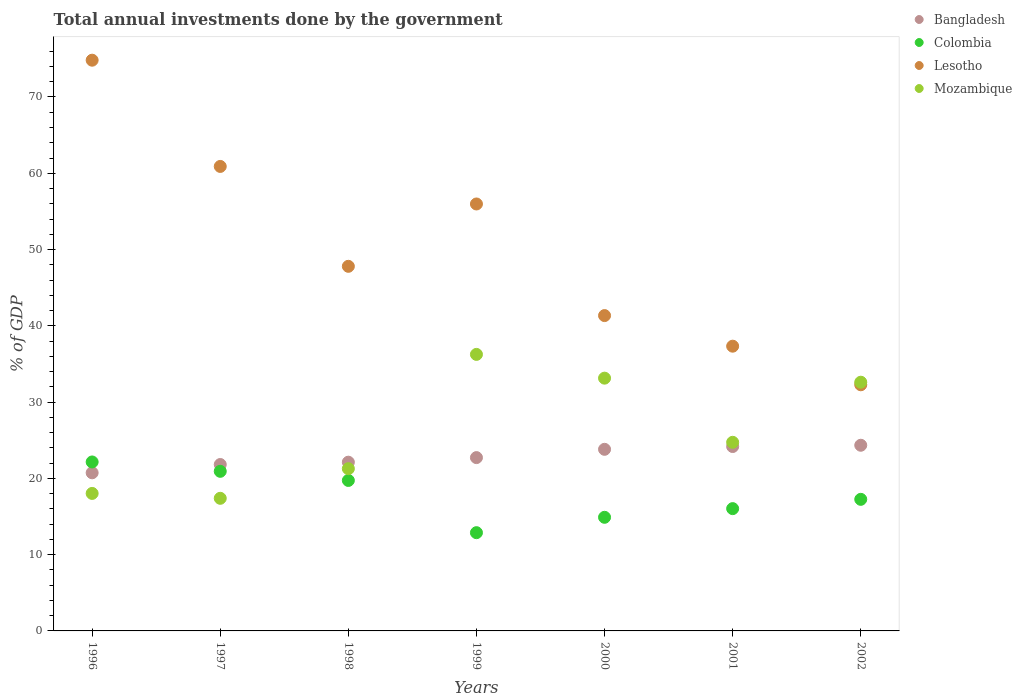How many different coloured dotlines are there?
Offer a very short reply. 4. What is the total annual investments done by the government in Bangladesh in 1997?
Offer a very short reply. 21.82. Across all years, what is the maximum total annual investments done by the government in Lesotho?
Make the answer very short. 74.82. Across all years, what is the minimum total annual investments done by the government in Lesotho?
Your answer should be compact. 32.27. In which year was the total annual investments done by the government in Bangladesh minimum?
Make the answer very short. 1996. What is the total total annual investments done by the government in Lesotho in the graph?
Offer a very short reply. 350.43. What is the difference between the total annual investments done by the government in Lesotho in 1996 and that in 1997?
Provide a short and direct response. 13.93. What is the difference between the total annual investments done by the government in Bangladesh in 1999 and the total annual investments done by the government in Colombia in 1996?
Make the answer very short. 0.57. What is the average total annual investments done by the government in Lesotho per year?
Offer a terse response. 50.06. In the year 1998, what is the difference between the total annual investments done by the government in Colombia and total annual investments done by the government in Bangladesh?
Provide a succinct answer. -2.39. What is the ratio of the total annual investments done by the government in Mozambique in 1997 to that in 1998?
Keep it short and to the point. 0.82. Is the total annual investments done by the government in Bangladesh in 1996 less than that in 2001?
Offer a terse response. Yes. What is the difference between the highest and the second highest total annual investments done by the government in Mozambique?
Give a very brief answer. 3.12. What is the difference between the highest and the lowest total annual investments done by the government in Colombia?
Your response must be concise. 9.27. Is it the case that in every year, the sum of the total annual investments done by the government in Lesotho and total annual investments done by the government in Mozambique  is greater than the sum of total annual investments done by the government in Colombia and total annual investments done by the government in Bangladesh?
Provide a short and direct response. Yes. Is it the case that in every year, the sum of the total annual investments done by the government in Colombia and total annual investments done by the government in Lesotho  is greater than the total annual investments done by the government in Bangladesh?
Provide a short and direct response. Yes. Is the total annual investments done by the government in Colombia strictly greater than the total annual investments done by the government in Bangladesh over the years?
Offer a terse response. No. How many dotlines are there?
Give a very brief answer. 4. How many years are there in the graph?
Give a very brief answer. 7. What is the difference between two consecutive major ticks on the Y-axis?
Offer a very short reply. 10. Are the values on the major ticks of Y-axis written in scientific E-notation?
Your answer should be compact. No. How many legend labels are there?
Provide a short and direct response. 4. How are the legend labels stacked?
Your answer should be compact. Vertical. What is the title of the graph?
Keep it short and to the point. Total annual investments done by the government. What is the label or title of the Y-axis?
Make the answer very short. % of GDP. What is the % of GDP in Bangladesh in 1996?
Your answer should be compact. 20.73. What is the % of GDP of Colombia in 1996?
Your answer should be very brief. 22.15. What is the % of GDP of Lesotho in 1996?
Make the answer very short. 74.82. What is the % of GDP of Mozambique in 1996?
Keep it short and to the point. 18.03. What is the % of GDP of Bangladesh in 1997?
Ensure brevity in your answer.  21.82. What is the % of GDP in Colombia in 1997?
Offer a terse response. 20.92. What is the % of GDP in Lesotho in 1997?
Keep it short and to the point. 60.89. What is the % of GDP of Mozambique in 1997?
Offer a terse response. 17.39. What is the % of GDP in Bangladesh in 1998?
Provide a short and direct response. 22.12. What is the % of GDP in Colombia in 1998?
Make the answer very short. 19.73. What is the % of GDP in Lesotho in 1998?
Give a very brief answer. 47.8. What is the % of GDP in Mozambique in 1998?
Your answer should be compact. 21.27. What is the % of GDP of Bangladesh in 1999?
Make the answer very short. 22.72. What is the % of GDP in Colombia in 1999?
Provide a succinct answer. 12.88. What is the % of GDP of Lesotho in 1999?
Make the answer very short. 55.97. What is the % of GDP in Mozambique in 1999?
Make the answer very short. 36.25. What is the % of GDP of Bangladesh in 2000?
Give a very brief answer. 23.81. What is the % of GDP of Colombia in 2000?
Provide a short and direct response. 14.9. What is the % of GDP of Lesotho in 2000?
Your answer should be very brief. 41.34. What is the % of GDP of Mozambique in 2000?
Give a very brief answer. 33.14. What is the % of GDP of Bangladesh in 2001?
Offer a very short reply. 24.17. What is the % of GDP in Colombia in 2001?
Your response must be concise. 16.03. What is the % of GDP in Lesotho in 2001?
Give a very brief answer. 37.33. What is the % of GDP in Mozambique in 2001?
Make the answer very short. 24.73. What is the % of GDP in Bangladesh in 2002?
Give a very brief answer. 24.34. What is the % of GDP of Colombia in 2002?
Offer a very short reply. 17.25. What is the % of GDP of Lesotho in 2002?
Your answer should be very brief. 32.27. What is the % of GDP in Mozambique in 2002?
Provide a succinct answer. 32.61. Across all years, what is the maximum % of GDP in Bangladesh?
Your answer should be very brief. 24.34. Across all years, what is the maximum % of GDP in Colombia?
Your answer should be compact. 22.15. Across all years, what is the maximum % of GDP of Lesotho?
Make the answer very short. 74.82. Across all years, what is the maximum % of GDP of Mozambique?
Make the answer very short. 36.25. Across all years, what is the minimum % of GDP in Bangladesh?
Your response must be concise. 20.73. Across all years, what is the minimum % of GDP in Colombia?
Give a very brief answer. 12.88. Across all years, what is the minimum % of GDP of Lesotho?
Offer a terse response. 32.27. Across all years, what is the minimum % of GDP in Mozambique?
Your answer should be very brief. 17.39. What is the total % of GDP in Bangladesh in the graph?
Offer a terse response. 159.71. What is the total % of GDP of Colombia in the graph?
Offer a very short reply. 123.86. What is the total % of GDP in Lesotho in the graph?
Ensure brevity in your answer.  350.43. What is the total % of GDP in Mozambique in the graph?
Provide a short and direct response. 183.41. What is the difference between the % of GDP of Bangladesh in 1996 and that in 1997?
Offer a very short reply. -1.09. What is the difference between the % of GDP of Colombia in 1996 and that in 1997?
Your response must be concise. 1.23. What is the difference between the % of GDP in Lesotho in 1996 and that in 1997?
Make the answer very short. 13.93. What is the difference between the % of GDP in Mozambique in 1996 and that in 1997?
Your answer should be very brief. 0.64. What is the difference between the % of GDP of Bangladesh in 1996 and that in 1998?
Keep it short and to the point. -1.39. What is the difference between the % of GDP of Colombia in 1996 and that in 1998?
Offer a terse response. 2.42. What is the difference between the % of GDP in Lesotho in 1996 and that in 1998?
Provide a short and direct response. 27.02. What is the difference between the % of GDP of Mozambique in 1996 and that in 1998?
Offer a very short reply. -3.24. What is the difference between the % of GDP of Bangladesh in 1996 and that in 1999?
Offer a very short reply. -1.99. What is the difference between the % of GDP of Colombia in 1996 and that in 1999?
Provide a succinct answer. 9.27. What is the difference between the % of GDP of Lesotho in 1996 and that in 1999?
Offer a terse response. 18.85. What is the difference between the % of GDP in Mozambique in 1996 and that in 1999?
Your answer should be compact. -18.23. What is the difference between the % of GDP in Bangladesh in 1996 and that in 2000?
Offer a very short reply. -3.08. What is the difference between the % of GDP of Colombia in 1996 and that in 2000?
Your answer should be compact. 7.26. What is the difference between the % of GDP in Lesotho in 1996 and that in 2000?
Your response must be concise. 33.48. What is the difference between the % of GDP in Mozambique in 1996 and that in 2000?
Give a very brief answer. -15.11. What is the difference between the % of GDP of Bangladesh in 1996 and that in 2001?
Offer a very short reply. -3.44. What is the difference between the % of GDP of Colombia in 1996 and that in 2001?
Offer a terse response. 6.12. What is the difference between the % of GDP in Lesotho in 1996 and that in 2001?
Provide a short and direct response. 37.49. What is the difference between the % of GDP of Mozambique in 1996 and that in 2001?
Ensure brevity in your answer.  -6.7. What is the difference between the % of GDP in Bangladesh in 1996 and that in 2002?
Your answer should be very brief. -3.61. What is the difference between the % of GDP of Colombia in 1996 and that in 2002?
Offer a terse response. 4.9. What is the difference between the % of GDP in Lesotho in 1996 and that in 2002?
Provide a succinct answer. 42.55. What is the difference between the % of GDP in Mozambique in 1996 and that in 2002?
Keep it short and to the point. -14.58. What is the difference between the % of GDP of Bangladesh in 1997 and that in 1998?
Keep it short and to the point. -0.31. What is the difference between the % of GDP of Colombia in 1997 and that in 1998?
Your answer should be very brief. 1.2. What is the difference between the % of GDP of Lesotho in 1997 and that in 1998?
Your answer should be very brief. 13.1. What is the difference between the % of GDP in Mozambique in 1997 and that in 1998?
Provide a short and direct response. -3.88. What is the difference between the % of GDP in Bangladesh in 1997 and that in 1999?
Offer a terse response. -0.91. What is the difference between the % of GDP of Colombia in 1997 and that in 1999?
Provide a short and direct response. 8.04. What is the difference between the % of GDP in Lesotho in 1997 and that in 1999?
Provide a succinct answer. 4.92. What is the difference between the % of GDP of Mozambique in 1997 and that in 1999?
Your answer should be compact. -18.87. What is the difference between the % of GDP of Bangladesh in 1997 and that in 2000?
Offer a very short reply. -1.99. What is the difference between the % of GDP in Colombia in 1997 and that in 2000?
Your answer should be compact. 6.03. What is the difference between the % of GDP of Lesotho in 1997 and that in 2000?
Keep it short and to the point. 19.55. What is the difference between the % of GDP in Mozambique in 1997 and that in 2000?
Give a very brief answer. -15.75. What is the difference between the % of GDP in Bangladesh in 1997 and that in 2001?
Offer a terse response. -2.36. What is the difference between the % of GDP in Colombia in 1997 and that in 2001?
Your response must be concise. 4.89. What is the difference between the % of GDP in Lesotho in 1997 and that in 2001?
Provide a short and direct response. 23.57. What is the difference between the % of GDP of Mozambique in 1997 and that in 2001?
Your answer should be compact. -7.34. What is the difference between the % of GDP in Bangladesh in 1997 and that in 2002?
Your response must be concise. -2.53. What is the difference between the % of GDP in Colombia in 1997 and that in 2002?
Provide a succinct answer. 3.67. What is the difference between the % of GDP of Lesotho in 1997 and that in 2002?
Provide a short and direct response. 28.62. What is the difference between the % of GDP in Mozambique in 1997 and that in 2002?
Give a very brief answer. -15.22. What is the difference between the % of GDP of Colombia in 1998 and that in 1999?
Your response must be concise. 6.85. What is the difference between the % of GDP of Lesotho in 1998 and that in 1999?
Give a very brief answer. -8.17. What is the difference between the % of GDP in Mozambique in 1998 and that in 1999?
Your answer should be compact. -14.98. What is the difference between the % of GDP of Bangladesh in 1998 and that in 2000?
Your answer should be very brief. -1.69. What is the difference between the % of GDP in Colombia in 1998 and that in 2000?
Keep it short and to the point. 4.83. What is the difference between the % of GDP in Lesotho in 1998 and that in 2000?
Your response must be concise. 6.46. What is the difference between the % of GDP of Mozambique in 1998 and that in 2000?
Keep it short and to the point. -11.87. What is the difference between the % of GDP in Bangladesh in 1998 and that in 2001?
Make the answer very short. -2.05. What is the difference between the % of GDP of Colombia in 1998 and that in 2001?
Your answer should be compact. 3.7. What is the difference between the % of GDP of Lesotho in 1998 and that in 2001?
Make the answer very short. 10.47. What is the difference between the % of GDP in Mozambique in 1998 and that in 2001?
Provide a short and direct response. -3.46. What is the difference between the % of GDP in Bangladesh in 1998 and that in 2002?
Ensure brevity in your answer.  -2.22. What is the difference between the % of GDP in Colombia in 1998 and that in 2002?
Your response must be concise. 2.48. What is the difference between the % of GDP in Lesotho in 1998 and that in 2002?
Make the answer very short. 15.53. What is the difference between the % of GDP in Mozambique in 1998 and that in 2002?
Offer a very short reply. -11.34. What is the difference between the % of GDP of Bangladesh in 1999 and that in 2000?
Ensure brevity in your answer.  -1.09. What is the difference between the % of GDP of Colombia in 1999 and that in 2000?
Keep it short and to the point. -2.02. What is the difference between the % of GDP in Lesotho in 1999 and that in 2000?
Offer a terse response. 14.63. What is the difference between the % of GDP of Mozambique in 1999 and that in 2000?
Provide a succinct answer. 3.12. What is the difference between the % of GDP of Bangladesh in 1999 and that in 2001?
Provide a short and direct response. -1.45. What is the difference between the % of GDP in Colombia in 1999 and that in 2001?
Provide a succinct answer. -3.15. What is the difference between the % of GDP in Lesotho in 1999 and that in 2001?
Keep it short and to the point. 18.64. What is the difference between the % of GDP of Mozambique in 1999 and that in 2001?
Your answer should be compact. 11.53. What is the difference between the % of GDP of Bangladesh in 1999 and that in 2002?
Give a very brief answer. -1.62. What is the difference between the % of GDP in Colombia in 1999 and that in 2002?
Your response must be concise. -4.37. What is the difference between the % of GDP of Lesotho in 1999 and that in 2002?
Provide a succinct answer. 23.7. What is the difference between the % of GDP of Mozambique in 1999 and that in 2002?
Provide a short and direct response. 3.65. What is the difference between the % of GDP in Bangladesh in 2000 and that in 2001?
Offer a very short reply. -0.37. What is the difference between the % of GDP of Colombia in 2000 and that in 2001?
Offer a very short reply. -1.14. What is the difference between the % of GDP in Lesotho in 2000 and that in 2001?
Ensure brevity in your answer.  4.01. What is the difference between the % of GDP of Mozambique in 2000 and that in 2001?
Offer a terse response. 8.41. What is the difference between the % of GDP in Bangladesh in 2000 and that in 2002?
Offer a terse response. -0.53. What is the difference between the % of GDP in Colombia in 2000 and that in 2002?
Give a very brief answer. -2.36. What is the difference between the % of GDP in Lesotho in 2000 and that in 2002?
Provide a short and direct response. 9.07. What is the difference between the % of GDP of Mozambique in 2000 and that in 2002?
Offer a terse response. 0.53. What is the difference between the % of GDP of Bangladesh in 2001 and that in 2002?
Make the answer very short. -0.17. What is the difference between the % of GDP in Colombia in 2001 and that in 2002?
Give a very brief answer. -1.22. What is the difference between the % of GDP in Lesotho in 2001 and that in 2002?
Ensure brevity in your answer.  5.06. What is the difference between the % of GDP in Mozambique in 2001 and that in 2002?
Your answer should be very brief. -7.88. What is the difference between the % of GDP in Bangladesh in 1996 and the % of GDP in Colombia in 1997?
Provide a succinct answer. -0.19. What is the difference between the % of GDP of Bangladesh in 1996 and the % of GDP of Lesotho in 1997?
Offer a very short reply. -40.16. What is the difference between the % of GDP in Bangladesh in 1996 and the % of GDP in Mozambique in 1997?
Ensure brevity in your answer.  3.34. What is the difference between the % of GDP of Colombia in 1996 and the % of GDP of Lesotho in 1997?
Your answer should be compact. -38.74. What is the difference between the % of GDP in Colombia in 1996 and the % of GDP in Mozambique in 1997?
Keep it short and to the point. 4.77. What is the difference between the % of GDP of Lesotho in 1996 and the % of GDP of Mozambique in 1997?
Give a very brief answer. 57.44. What is the difference between the % of GDP in Bangladesh in 1996 and the % of GDP in Colombia in 1998?
Keep it short and to the point. 1. What is the difference between the % of GDP of Bangladesh in 1996 and the % of GDP of Lesotho in 1998?
Your answer should be very brief. -27.07. What is the difference between the % of GDP in Bangladesh in 1996 and the % of GDP in Mozambique in 1998?
Make the answer very short. -0.54. What is the difference between the % of GDP of Colombia in 1996 and the % of GDP of Lesotho in 1998?
Ensure brevity in your answer.  -25.65. What is the difference between the % of GDP of Colombia in 1996 and the % of GDP of Mozambique in 1998?
Offer a terse response. 0.88. What is the difference between the % of GDP in Lesotho in 1996 and the % of GDP in Mozambique in 1998?
Your answer should be compact. 53.55. What is the difference between the % of GDP in Bangladesh in 1996 and the % of GDP in Colombia in 1999?
Your answer should be compact. 7.85. What is the difference between the % of GDP of Bangladesh in 1996 and the % of GDP of Lesotho in 1999?
Offer a very short reply. -35.24. What is the difference between the % of GDP of Bangladesh in 1996 and the % of GDP of Mozambique in 1999?
Your response must be concise. -15.52. What is the difference between the % of GDP in Colombia in 1996 and the % of GDP in Lesotho in 1999?
Your answer should be compact. -33.82. What is the difference between the % of GDP in Colombia in 1996 and the % of GDP in Mozambique in 1999?
Give a very brief answer. -14.1. What is the difference between the % of GDP in Lesotho in 1996 and the % of GDP in Mozambique in 1999?
Your answer should be compact. 38.57. What is the difference between the % of GDP of Bangladesh in 1996 and the % of GDP of Colombia in 2000?
Make the answer very short. 5.83. What is the difference between the % of GDP of Bangladesh in 1996 and the % of GDP of Lesotho in 2000?
Your answer should be very brief. -20.61. What is the difference between the % of GDP in Bangladesh in 1996 and the % of GDP in Mozambique in 2000?
Provide a short and direct response. -12.41. What is the difference between the % of GDP of Colombia in 1996 and the % of GDP of Lesotho in 2000?
Provide a succinct answer. -19.19. What is the difference between the % of GDP of Colombia in 1996 and the % of GDP of Mozambique in 2000?
Keep it short and to the point. -10.99. What is the difference between the % of GDP in Lesotho in 1996 and the % of GDP in Mozambique in 2000?
Provide a succinct answer. 41.68. What is the difference between the % of GDP in Bangladesh in 1996 and the % of GDP in Colombia in 2001?
Give a very brief answer. 4.7. What is the difference between the % of GDP in Bangladesh in 1996 and the % of GDP in Lesotho in 2001?
Offer a very short reply. -16.6. What is the difference between the % of GDP in Bangladesh in 1996 and the % of GDP in Mozambique in 2001?
Give a very brief answer. -4. What is the difference between the % of GDP in Colombia in 1996 and the % of GDP in Lesotho in 2001?
Provide a short and direct response. -15.18. What is the difference between the % of GDP in Colombia in 1996 and the % of GDP in Mozambique in 2001?
Give a very brief answer. -2.58. What is the difference between the % of GDP in Lesotho in 1996 and the % of GDP in Mozambique in 2001?
Keep it short and to the point. 50.09. What is the difference between the % of GDP of Bangladesh in 1996 and the % of GDP of Colombia in 2002?
Make the answer very short. 3.48. What is the difference between the % of GDP of Bangladesh in 1996 and the % of GDP of Lesotho in 2002?
Offer a terse response. -11.54. What is the difference between the % of GDP of Bangladesh in 1996 and the % of GDP of Mozambique in 2002?
Offer a very short reply. -11.88. What is the difference between the % of GDP in Colombia in 1996 and the % of GDP in Lesotho in 2002?
Provide a succinct answer. -10.12. What is the difference between the % of GDP in Colombia in 1996 and the % of GDP in Mozambique in 2002?
Keep it short and to the point. -10.46. What is the difference between the % of GDP in Lesotho in 1996 and the % of GDP in Mozambique in 2002?
Your response must be concise. 42.22. What is the difference between the % of GDP in Bangladesh in 1997 and the % of GDP in Colombia in 1998?
Your answer should be very brief. 2.09. What is the difference between the % of GDP of Bangladesh in 1997 and the % of GDP of Lesotho in 1998?
Your answer should be very brief. -25.98. What is the difference between the % of GDP in Bangladesh in 1997 and the % of GDP in Mozambique in 1998?
Make the answer very short. 0.55. What is the difference between the % of GDP of Colombia in 1997 and the % of GDP of Lesotho in 1998?
Your answer should be compact. -26.88. What is the difference between the % of GDP in Colombia in 1997 and the % of GDP in Mozambique in 1998?
Make the answer very short. -0.35. What is the difference between the % of GDP of Lesotho in 1997 and the % of GDP of Mozambique in 1998?
Keep it short and to the point. 39.63. What is the difference between the % of GDP of Bangladesh in 1997 and the % of GDP of Colombia in 1999?
Make the answer very short. 8.94. What is the difference between the % of GDP of Bangladesh in 1997 and the % of GDP of Lesotho in 1999?
Make the answer very short. -34.16. What is the difference between the % of GDP of Bangladesh in 1997 and the % of GDP of Mozambique in 1999?
Your answer should be very brief. -14.44. What is the difference between the % of GDP in Colombia in 1997 and the % of GDP in Lesotho in 1999?
Provide a short and direct response. -35.05. What is the difference between the % of GDP of Colombia in 1997 and the % of GDP of Mozambique in 1999?
Offer a very short reply. -15.33. What is the difference between the % of GDP in Lesotho in 1997 and the % of GDP in Mozambique in 1999?
Ensure brevity in your answer.  24.64. What is the difference between the % of GDP of Bangladesh in 1997 and the % of GDP of Colombia in 2000?
Offer a terse response. 6.92. What is the difference between the % of GDP of Bangladesh in 1997 and the % of GDP of Lesotho in 2000?
Give a very brief answer. -19.52. What is the difference between the % of GDP of Bangladesh in 1997 and the % of GDP of Mozambique in 2000?
Make the answer very short. -11.32. What is the difference between the % of GDP in Colombia in 1997 and the % of GDP in Lesotho in 2000?
Give a very brief answer. -20.42. What is the difference between the % of GDP in Colombia in 1997 and the % of GDP in Mozambique in 2000?
Offer a very short reply. -12.21. What is the difference between the % of GDP of Lesotho in 1997 and the % of GDP of Mozambique in 2000?
Make the answer very short. 27.76. What is the difference between the % of GDP of Bangladesh in 1997 and the % of GDP of Colombia in 2001?
Provide a short and direct response. 5.78. What is the difference between the % of GDP of Bangladesh in 1997 and the % of GDP of Lesotho in 2001?
Give a very brief answer. -15.51. What is the difference between the % of GDP in Bangladesh in 1997 and the % of GDP in Mozambique in 2001?
Your response must be concise. -2.91. What is the difference between the % of GDP in Colombia in 1997 and the % of GDP in Lesotho in 2001?
Provide a short and direct response. -16.41. What is the difference between the % of GDP in Colombia in 1997 and the % of GDP in Mozambique in 2001?
Offer a terse response. -3.8. What is the difference between the % of GDP in Lesotho in 1997 and the % of GDP in Mozambique in 2001?
Your response must be concise. 36.17. What is the difference between the % of GDP of Bangladesh in 1997 and the % of GDP of Colombia in 2002?
Your response must be concise. 4.56. What is the difference between the % of GDP of Bangladesh in 1997 and the % of GDP of Lesotho in 2002?
Make the answer very short. -10.45. What is the difference between the % of GDP in Bangladesh in 1997 and the % of GDP in Mozambique in 2002?
Your answer should be very brief. -10.79. What is the difference between the % of GDP in Colombia in 1997 and the % of GDP in Lesotho in 2002?
Keep it short and to the point. -11.35. What is the difference between the % of GDP of Colombia in 1997 and the % of GDP of Mozambique in 2002?
Your response must be concise. -11.68. What is the difference between the % of GDP in Lesotho in 1997 and the % of GDP in Mozambique in 2002?
Offer a terse response. 28.29. What is the difference between the % of GDP in Bangladesh in 1998 and the % of GDP in Colombia in 1999?
Provide a succinct answer. 9.24. What is the difference between the % of GDP in Bangladesh in 1998 and the % of GDP in Lesotho in 1999?
Offer a very short reply. -33.85. What is the difference between the % of GDP in Bangladesh in 1998 and the % of GDP in Mozambique in 1999?
Keep it short and to the point. -14.13. What is the difference between the % of GDP in Colombia in 1998 and the % of GDP in Lesotho in 1999?
Your answer should be compact. -36.24. What is the difference between the % of GDP of Colombia in 1998 and the % of GDP of Mozambique in 1999?
Your answer should be compact. -16.53. What is the difference between the % of GDP of Lesotho in 1998 and the % of GDP of Mozambique in 1999?
Ensure brevity in your answer.  11.55. What is the difference between the % of GDP in Bangladesh in 1998 and the % of GDP in Colombia in 2000?
Your answer should be very brief. 7.23. What is the difference between the % of GDP in Bangladesh in 1998 and the % of GDP in Lesotho in 2000?
Your answer should be compact. -19.22. What is the difference between the % of GDP in Bangladesh in 1998 and the % of GDP in Mozambique in 2000?
Offer a terse response. -11.02. What is the difference between the % of GDP in Colombia in 1998 and the % of GDP in Lesotho in 2000?
Your answer should be very brief. -21.61. What is the difference between the % of GDP in Colombia in 1998 and the % of GDP in Mozambique in 2000?
Provide a succinct answer. -13.41. What is the difference between the % of GDP in Lesotho in 1998 and the % of GDP in Mozambique in 2000?
Give a very brief answer. 14.66. What is the difference between the % of GDP in Bangladesh in 1998 and the % of GDP in Colombia in 2001?
Keep it short and to the point. 6.09. What is the difference between the % of GDP in Bangladesh in 1998 and the % of GDP in Lesotho in 2001?
Your response must be concise. -15.21. What is the difference between the % of GDP of Bangladesh in 1998 and the % of GDP of Mozambique in 2001?
Ensure brevity in your answer.  -2.61. What is the difference between the % of GDP in Colombia in 1998 and the % of GDP in Lesotho in 2001?
Give a very brief answer. -17.6. What is the difference between the % of GDP in Colombia in 1998 and the % of GDP in Mozambique in 2001?
Offer a very short reply. -5. What is the difference between the % of GDP in Lesotho in 1998 and the % of GDP in Mozambique in 2001?
Provide a short and direct response. 23.07. What is the difference between the % of GDP of Bangladesh in 1998 and the % of GDP of Colombia in 2002?
Keep it short and to the point. 4.87. What is the difference between the % of GDP of Bangladesh in 1998 and the % of GDP of Lesotho in 2002?
Provide a succinct answer. -10.15. What is the difference between the % of GDP in Bangladesh in 1998 and the % of GDP in Mozambique in 2002?
Your response must be concise. -10.49. What is the difference between the % of GDP in Colombia in 1998 and the % of GDP in Lesotho in 2002?
Make the answer very short. -12.54. What is the difference between the % of GDP of Colombia in 1998 and the % of GDP of Mozambique in 2002?
Your response must be concise. -12.88. What is the difference between the % of GDP in Lesotho in 1998 and the % of GDP in Mozambique in 2002?
Your answer should be very brief. 15.19. What is the difference between the % of GDP in Bangladesh in 1999 and the % of GDP in Colombia in 2000?
Your response must be concise. 7.83. What is the difference between the % of GDP of Bangladesh in 1999 and the % of GDP of Lesotho in 2000?
Provide a succinct answer. -18.62. What is the difference between the % of GDP in Bangladesh in 1999 and the % of GDP in Mozambique in 2000?
Provide a short and direct response. -10.42. What is the difference between the % of GDP of Colombia in 1999 and the % of GDP of Lesotho in 2000?
Your answer should be very brief. -28.46. What is the difference between the % of GDP in Colombia in 1999 and the % of GDP in Mozambique in 2000?
Offer a very short reply. -20.26. What is the difference between the % of GDP in Lesotho in 1999 and the % of GDP in Mozambique in 2000?
Your answer should be very brief. 22.84. What is the difference between the % of GDP of Bangladesh in 1999 and the % of GDP of Colombia in 2001?
Keep it short and to the point. 6.69. What is the difference between the % of GDP in Bangladesh in 1999 and the % of GDP in Lesotho in 2001?
Your answer should be very brief. -14.61. What is the difference between the % of GDP in Bangladesh in 1999 and the % of GDP in Mozambique in 2001?
Keep it short and to the point. -2.01. What is the difference between the % of GDP in Colombia in 1999 and the % of GDP in Lesotho in 2001?
Offer a terse response. -24.45. What is the difference between the % of GDP of Colombia in 1999 and the % of GDP of Mozambique in 2001?
Your answer should be compact. -11.85. What is the difference between the % of GDP of Lesotho in 1999 and the % of GDP of Mozambique in 2001?
Your answer should be very brief. 31.25. What is the difference between the % of GDP of Bangladesh in 1999 and the % of GDP of Colombia in 2002?
Your answer should be very brief. 5.47. What is the difference between the % of GDP of Bangladesh in 1999 and the % of GDP of Lesotho in 2002?
Provide a short and direct response. -9.55. What is the difference between the % of GDP in Bangladesh in 1999 and the % of GDP in Mozambique in 2002?
Your answer should be compact. -9.89. What is the difference between the % of GDP in Colombia in 1999 and the % of GDP in Lesotho in 2002?
Your answer should be compact. -19.39. What is the difference between the % of GDP in Colombia in 1999 and the % of GDP in Mozambique in 2002?
Keep it short and to the point. -19.73. What is the difference between the % of GDP of Lesotho in 1999 and the % of GDP of Mozambique in 2002?
Provide a succinct answer. 23.37. What is the difference between the % of GDP of Bangladesh in 2000 and the % of GDP of Colombia in 2001?
Keep it short and to the point. 7.78. What is the difference between the % of GDP in Bangladesh in 2000 and the % of GDP in Lesotho in 2001?
Offer a terse response. -13.52. What is the difference between the % of GDP in Bangladesh in 2000 and the % of GDP in Mozambique in 2001?
Make the answer very short. -0.92. What is the difference between the % of GDP in Colombia in 2000 and the % of GDP in Lesotho in 2001?
Make the answer very short. -22.43. What is the difference between the % of GDP in Colombia in 2000 and the % of GDP in Mozambique in 2001?
Give a very brief answer. -9.83. What is the difference between the % of GDP of Lesotho in 2000 and the % of GDP of Mozambique in 2001?
Keep it short and to the point. 16.61. What is the difference between the % of GDP in Bangladesh in 2000 and the % of GDP in Colombia in 2002?
Provide a short and direct response. 6.56. What is the difference between the % of GDP of Bangladesh in 2000 and the % of GDP of Lesotho in 2002?
Provide a short and direct response. -8.46. What is the difference between the % of GDP in Bangladesh in 2000 and the % of GDP in Mozambique in 2002?
Ensure brevity in your answer.  -8.8. What is the difference between the % of GDP of Colombia in 2000 and the % of GDP of Lesotho in 2002?
Provide a succinct answer. -17.38. What is the difference between the % of GDP of Colombia in 2000 and the % of GDP of Mozambique in 2002?
Your answer should be very brief. -17.71. What is the difference between the % of GDP in Lesotho in 2000 and the % of GDP in Mozambique in 2002?
Provide a short and direct response. 8.73. What is the difference between the % of GDP of Bangladesh in 2001 and the % of GDP of Colombia in 2002?
Your response must be concise. 6.92. What is the difference between the % of GDP of Bangladesh in 2001 and the % of GDP of Lesotho in 2002?
Keep it short and to the point. -8.1. What is the difference between the % of GDP of Bangladesh in 2001 and the % of GDP of Mozambique in 2002?
Make the answer very short. -8.43. What is the difference between the % of GDP of Colombia in 2001 and the % of GDP of Lesotho in 2002?
Provide a succinct answer. -16.24. What is the difference between the % of GDP of Colombia in 2001 and the % of GDP of Mozambique in 2002?
Provide a succinct answer. -16.57. What is the difference between the % of GDP in Lesotho in 2001 and the % of GDP in Mozambique in 2002?
Your answer should be very brief. 4.72. What is the average % of GDP in Bangladesh per year?
Your answer should be compact. 22.82. What is the average % of GDP of Colombia per year?
Your answer should be compact. 17.69. What is the average % of GDP of Lesotho per year?
Make the answer very short. 50.06. What is the average % of GDP in Mozambique per year?
Offer a terse response. 26.2. In the year 1996, what is the difference between the % of GDP of Bangladesh and % of GDP of Colombia?
Keep it short and to the point. -1.42. In the year 1996, what is the difference between the % of GDP in Bangladesh and % of GDP in Lesotho?
Your answer should be very brief. -54.09. In the year 1996, what is the difference between the % of GDP of Bangladesh and % of GDP of Mozambique?
Offer a very short reply. 2.7. In the year 1996, what is the difference between the % of GDP in Colombia and % of GDP in Lesotho?
Your answer should be compact. -52.67. In the year 1996, what is the difference between the % of GDP in Colombia and % of GDP in Mozambique?
Offer a very short reply. 4.12. In the year 1996, what is the difference between the % of GDP in Lesotho and % of GDP in Mozambique?
Give a very brief answer. 56.8. In the year 1997, what is the difference between the % of GDP in Bangladesh and % of GDP in Colombia?
Offer a very short reply. 0.89. In the year 1997, what is the difference between the % of GDP of Bangladesh and % of GDP of Lesotho?
Your answer should be very brief. -39.08. In the year 1997, what is the difference between the % of GDP in Bangladesh and % of GDP in Mozambique?
Your answer should be compact. 4.43. In the year 1997, what is the difference between the % of GDP of Colombia and % of GDP of Lesotho?
Your response must be concise. -39.97. In the year 1997, what is the difference between the % of GDP of Colombia and % of GDP of Mozambique?
Ensure brevity in your answer.  3.54. In the year 1997, what is the difference between the % of GDP in Lesotho and % of GDP in Mozambique?
Make the answer very short. 43.51. In the year 1998, what is the difference between the % of GDP in Bangladesh and % of GDP in Colombia?
Ensure brevity in your answer.  2.39. In the year 1998, what is the difference between the % of GDP of Bangladesh and % of GDP of Lesotho?
Your answer should be very brief. -25.68. In the year 1998, what is the difference between the % of GDP of Bangladesh and % of GDP of Mozambique?
Your answer should be compact. 0.85. In the year 1998, what is the difference between the % of GDP of Colombia and % of GDP of Lesotho?
Your response must be concise. -28.07. In the year 1998, what is the difference between the % of GDP of Colombia and % of GDP of Mozambique?
Provide a short and direct response. -1.54. In the year 1998, what is the difference between the % of GDP in Lesotho and % of GDP in Mozambique?
Your answer should be very brief. 26.53. In the year 1999, what is the difference between the % of GDP in Bangladesh and % of GDP in Colombia?
Make the answer very short. 9.84. In the year 1999, what is the difference between the % of GDP in Bangladesh and % of GDP in Lesotho?
Your answer should be compact. -33.25. In the year 1999, what is the difference between the % of GDP of Bangladesh and % of GDP of Mozambique?
Your answer should be compact. -13.53. In the year 1999, what is the difference between the % of GDP in Colombia and % of GDP in Lesotho?
Offer a very short reply. -43.09. In the year 1999, what is the difference between the % of GDP in Colombia and % of GDP in Mozambique?
Your response must be concise. -23.37. In the year 1999, what is the difference between the % of GDP in Lesotho and % of GDP in Mozambique?
Provide a succinct answer. 19.72. In the year 2000, what is the difference between the % of GDP in Bangladesh and % of GDP in Colombia?
Your answer should be compact. 8.91. In the year 2000, what is the difference between the % of GDP in Bangladesh and % of GDP in Lesotho?
Give a very brief answer. -17.53. In the year 2000, what is the difference between the % of GDP in Bangladesh and % of GDP in Mozambique?
Provide a short and direct response. -9.33. In the year 2000, what is the difference between the % of GDP of Colombia and % of GDP of Lesotho?
Offer a terse response. -26.45. In the year 2000, what is the difference between the % of GDP of Colombia and % of GDP of Mozambique?
Provide a short and direct response. -18.24. In the year 2000, what is the difference between the % of GDP of Lesotho and % of GDP of Mozambique?
Your answer should be compact. 8.2. In the year 2001, what is the difference between the % of GDP in Bangladesh and % of GDP in Colombia?
Your response must be concise. 8.14. In the year 2001, what is the difference between the % of GDP of Bangladesh and % of GDP of Lesotho?
Your response must be concise. -13.15. In the year 2001, what is the difference between the % of GDP of Bangladesh and % of GDP of Mozambique?
Give a very brief answer. -0.55. In the year 2001, what is the difference between the % of GDP of Colombia and % of GDP of Lesotho?
Offer a terse response. -21.3. In the year 2001, what is the difference between the % of GDP in Colombia and % of GDP in Mozambique?
Your response must be concise. -8.7. In the year 2001, what is the difference between the % of GDP of Lesotho and % of GDP of Mozambique?
Provide a succinct answer. 12.6. In the year 2002, what is the difference between the % of GDP in Bangladesh and % of GDP in Colombia?
Provide a succinct answer. 7.09. In the year 2002, what is the difference between the % of GDP of Bangladesh and % of GDP of Lesotho?
Provide a succinct answer. -7.93. In the year 2002, what is the difference between the % of GDP in Bangladesh and % of GDP in Mozambique?
Your response must be concise. -8.27. In the year 2002, what is the difference between the % of GDP of Colombia and % of GDP of Lesotho?
Provide a short and direct response. -15.02. In the year 2002, what is the difference between the % of GDP of Colombia and % of GDP of Mozambique?
Your answer should be compact. -15.36. In the year 2002, what is the difference between the % of GDP of Lesotho and % of GDP of Mozambique?
Your answer should be compact. -0.34. What is the ratio of the % of GDP of Bangladesh in 1996 to that in 1997?
Offer a very short reply. 0.95. What is the ratio of the % of GDP of Colombia in 1996 to that in 1997?
Make the answer very short. 1.06. What is the ratio of the % of GDP in Lesotho in 1996 to that in 1997?
Your answer should be compact. 1.23. What is the ratio of the % of GDP of Mozambique in 1996 to that in 1997?
Keep it short and to the point. 1.04. What is the ratio of the % of GDP in Bangladesh in 1996 to that in 1998?
Offer a very short reply. 0.94. What is the ratio of the % of GDP of Colombia in 1996 to that in 1998?
Provide a short and direct response. 1.12. What is the ratio of the % of GDP of Lesotho in 1996 to that in 1998?
Keep it short and to the point. 1.57. What is the ratio of the % of GDP in Mozambique in 1996 to that in 1998?
Offer a very short reply. 0.85. What is the ratio of the % of GDP in Bangladesh in 1996 to that in 1999?
Offer a terse response. 0.91. What is the ratio of the % of GDP of Colombia in 1996 to that in 1999?
Your answer should be compact. 1.72. What is the ratio of the % of GDP in Lesotho in 1996 to that in 1999?
Make the answer very short. 1.34. What is the ratio of the % of GDP in Mozambique in 1996 to that in 1999?
Provide a succinct answer. 0.5. What is the ratio of the % of GDP of Bangladesh in 1996 to that in 2000?
Give a very brief answer. 0.87. What is the ratio of the % of GDP in Colombia in 1996 to that in 2000?
Offer a terse response. 1.49. What is the ratio of the % of GDP in Lesotho in 1996 to that in 2000?
Keep it short and to the point. 1.81. What is the ratio of the % of GDP of Mozambique in 1996 to that in 2000?
Provide a succinct answer. 0.54. What is the ratio of the % of GDP in Bangladesh in 1996 to that in 2001?
Your answer should be very brief. 0.86. What is the ratio of the % of GDP of Colombia in 1996 to that in 2001?
Ensure brevity in your answer.  1.38. What is the ratio of the % of GDP in Lesotho in 1996 to that in 2001?
Ensure brevity in your answer.  2. What is the ratio of the % of GDP in Mozambique in 1996 to that in 2001?
Provide a short and direct response. 0.73. What is the ratio of the % of GDP of Bangladesh in 1996 to that in 2002?
Keep it short and to the point. 0.85. What is the ratio of the % of GDP in Colombia in 1996 to that in 2002?
Offer a terse response. 1.28. What is the ratio of the % of GDP of Lesotho in 1996 to that in 2002?
Your answer should be compact. 2.32. What is the ratio of the % of GDP in Mozambique in 1996 to that in 2002?
Ensure brevity in your answer.  0.55. What is the ratio of the % of GDP of Bangladesh in 1997 to that in 1998?
Provide a short and direct response. 0.99. What is the ratio of the % of GDP of Colombia in 1997 to that in 1998?
Offer a very short reply. 1.06. What is the ratio of the % of GDP of Lesotho in 1997 to that in 1998?
Your answer should be very brief. 1.27. What is the ratio of the % of GDP in Mozambique in 1997 to that in 1998?
Your answer should be compact. 0.82. What is the ratio of the % of GDP of Bangladesh in 1997 to that in 1999?
Keep it short and to the point. 0.96. What is the ratio of the % of GDP of Colombia in 1997 to that in 1999?
Offer a very short reply. 1.62. What is the ratio of the % of GDP of Lesotho in 1997 to that in 1999?
Keep it short and to the point. 1.09. What is the ratio of the % of GDP of Mozambique in 1997 to that in 1999?
Provide a short and direct response. 0.48. What is the ratio of the % of GDP of Bangladesh in 1997 to that in 2000?
Your answer should be compact. 0.92. What is the ratio of the % of GDP of Colombia in 1997 to that in 2000?
Your answer should be compact. 1.4. What is the ratio of the % of GDP of Lesotho in 1997 to that in 2000?
Make the answer very short. 1.47. What is the ratio of the % of GDP of Mozambique in 1997 to that in 2000?
Provide a succinct answer. 0.52. What is the ratio of the % of GDP in Bangladesh in 1997 to that in 2001?
Offer a terse response. 0.9. What is the ratio of the % of GDP in Colombia in 1997 to that in 2001?
Offer a very short reply. 1.31. What is the ratio of the % of GDP in Lesotho in 1997 to that in 2001?
Provide a short and direct response. 1.63. What is the ratio of the % of GDP of Mozambique in 1997 to that in 2001?
Ensure brevity in your answer.  0.7. What is the ratio of the % of GDP in Bangladesh in 1997 to that in 2002?
Provide a short and direct response. 0.9. What is the ratio of the % of GDP in Colombia in 1997 to that in 2002?
Ensure brevity in your answer.  1.21. What is the ratio of the % of GDP of Lesotho in 1997 to that in 2002?
Provide a short and direct response. 1.89. What is the ratio of the % of GDP of Mozambique in 1997 to that in 2002?
Offer a terse response. 0.53. What is the ratio of the % of GDP of Bangladesh in 1998 to that in 1999?
Provide a succinct answer. 0.97. What is the ratio of the % of GDP of Colombia in 1998 to that in 1999?
Offer a very short reply. 1.53. What is the ratio of the % of GDP in Lesotho in 1998 to that in 1999?
Offer a very short reply. 0.85. What is the ratio of the % of GDP of Mozambique in 1998 to that in 1999?
Your answer should be compact. 0.59. What is the ratio of the % of GDP in Bangladesh in 1998 to that in 2000?
Your answer should be compact. 0.93. What is the ratio of the % of GDP in Colombia in 1998 to that in 2000?
Your answer should be compact. 1.32. What is the ratio of the % of GDP in Lesotho in 1998 to that in 2000?
Ensure brevity in your answer.  1.16. What is the ratio of the % of GDP in Mozambique in 1998 to that in 2000?
Your response must be concise. 0.64. What is the ratio of the % of GDP in Bangladesh in 1998 to that in 2001?
Offer a terse response. 0.92. What is the ratio of the % of GDP of Colombia in 1998 to that in 2001?
Provide a succinct answer. 1.23. What is the ratio of the % of GDP in Lesotho in 1998 to that in 2001?
Provide a short and direct response. 1.28. What is the ratio of the % of GDP in Mozambique in 1998 to that in 2001?
Your answer should be very brief. 0.86. What is the ratio of the % of GDP of Bangladesh in 1998 to that in 2002?
Provide a succinct answer. 0.91. What is the ratio of the % of GDP of Colombia in 1998 to that in 2002?
Make the answer very short. 1.14. What is the ratio of the % of GDP of Lesotho in 1998 to that in 2002?
Make the answer very short. 1.48. What is the ratio of the % of GDP of Mozambique in 1998 to that in 2002?
Ensure brevity in your answer.  0.65. What is the ratio of the % of GDP in Bangladesh in 1999 to that in 2000?
Keep it short and to the point. 0.95. What is the ratio of the % of GDP in Colombia in 1999 to that in 2000?
Provide a short and direct response. 0.86. What is the ratio of the % of GDP in Lesotho in 1999 to that in 2000?
Your response must be concise. 1.35. What is the ratio of the % of GDP of Mozambique in 1999 to that in 2000?
Your answer should be very brief. 1.09. What is the ratio of the % of GDP in Bangladesh in 1999 to that in 2001?
Your answer should be very brief. 0.94. What is the ratio of the % of GDP in Colombia in 1999 to that in 2001?
Keep it short and to the point. 0.8. What is the ratio of the % of GDP of Lesotho in 1999 to that in 2001?
Your answer should be compact. 1.5. What is the ratio of the % of GDP of Mozambique in 1999 to that in 2001?
Offer a terse response. 1.47. What is the ratio of the % of GDP in Bangladesh in 1999 to that in 2002?
Make the answer very short. 0.93. What is the ratio of the % of GDP of Colombia in 1999 to that in 2002?
Your answer should be very brief. 0.75. What is the ratio of the % of GDP of Lesotho in 1999 to that in 2002?
Make the answer very short. 1.73. What is the ratio of the % of GDP in Mozambique in 1999 to that in 2002?
Your answer should be very brief. 1.11. What is the ratio of the % of GDP of Bangladesh in 2000 to that in 2001?
Your answer should be compact. 0.98. What is the ratio of the % of GDP of Colombia in 2000 to that in 2001?
Make the answer very short. 0.93. What is the ratio of the % of GDP of Lesotho in 2000 to that in 2001?
Offer a terse response. 1.11. What is the ratio of the % of GDP of Mozambique in 2000 to that in 2001?
Your response must be concise. 1.34. What is the ratio of the % of GDP of Bangladesh in 2000 to that in 2002?
Make the answer very short. 0.98. What is the ratio of the % of GDP in Colombia in 2000 to that in 2002?
Offer a very short reply. 0.86. What is the ratio of the % of GDP of Lesotho in 2000 to that in 2002?
Provide a short and direct response. 1.28. What is the ratio of the % of GDP in Mozambique in 2000 to that in 2002?
Keep it short and to the point. 1.02. What is the ratio of the % of GDP of Bangladesh in 2001 to that in 2002?
Make the answer very short. 0.99. What is the ratio of the % of GDP in Colombia in 2001 to that in 2002?
Keep it short and to the point. 0.93. What is the ratio of the % of GDP in Lesotho in 2001 to that in 2002?
Give a very brief answer. 1.16. What is the ratio of the % of GDP of Mozambique in 2001 to that in 2002?
Make the answer very short. 0.76. What is the difference between the highest and the second highest % of GDP in Bangladesh?
Offer a very short reply. 0.17. What is the difference between the highest and the second highest % of GDP of Colombia?
Your response must be concise. 1.23. What is the difference between the highest and the second highest % of GDP in Lesotho?
Your response must be concise. 13.93. What is the difference between the highest and the second highest % of GDP of Mozambique?
Offer a very short reply. 3.12. What is the difference between the highest and the lowest % of GDP of Bangladesh?
Offer a very short reply. 3.61. What is the difference between the highest and the lowest % of GDP of Colombia?
Offer a very short reply. 9.27. What is the difference between the highest and the lowest % of GDP of Lesotho?
Offer a very short reply. 42.55. What is the difference between the highest and the lowest % of GDP of Mozambique?
Ensure brevity in your answer.  18.87. 